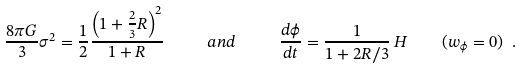<formula> <loc_0><loc_0><loc_500><loc_500>\frac { 8 \pi G } { 3 } \sigma ^ { 2 } = \frac { 1 } { 2 } \frac { \left ( 1 + \frac { 2 } { 3 } R \right ) ^ { 2 } } { 1 + R } \ \quad a n d \quad \ \frac { d \phi } { d t } = \frac { 1 } { 1 + 2 R / 3 } \, H \quad ( w _ { \phi } = 0 ) \ . \</formula> 